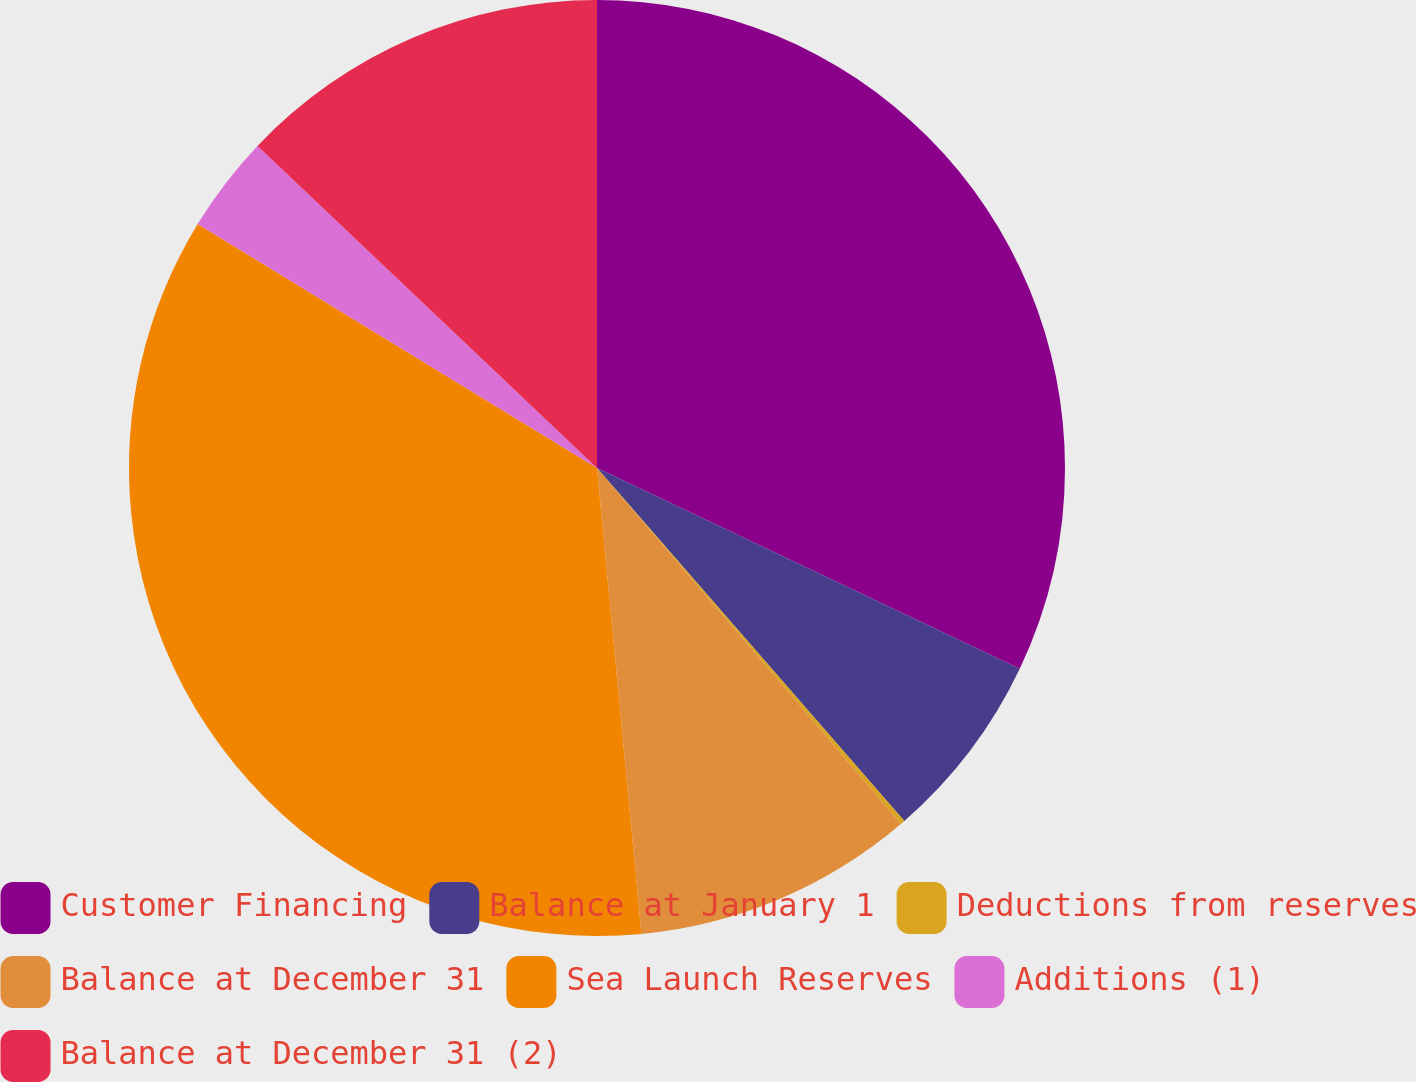Convert chart. <chart><loc_0><loc_0><loc_500><loc_500><pie_chart><fcel>Customer Financing<fcel>Balance at January 1<fcel>Deductions from reserves<fcel>Balance at December 31<fcel>Sea Launch Reserves<fcel>Additions (1)<fcel>Balance at December 31 (2)<nl><fcel>32.06%<fcel>6.54%<fcel>0.16%<fcel>9.73%<fcel>35.25%<fcel>3.35%<fcel>12.92%<nl></chart> 